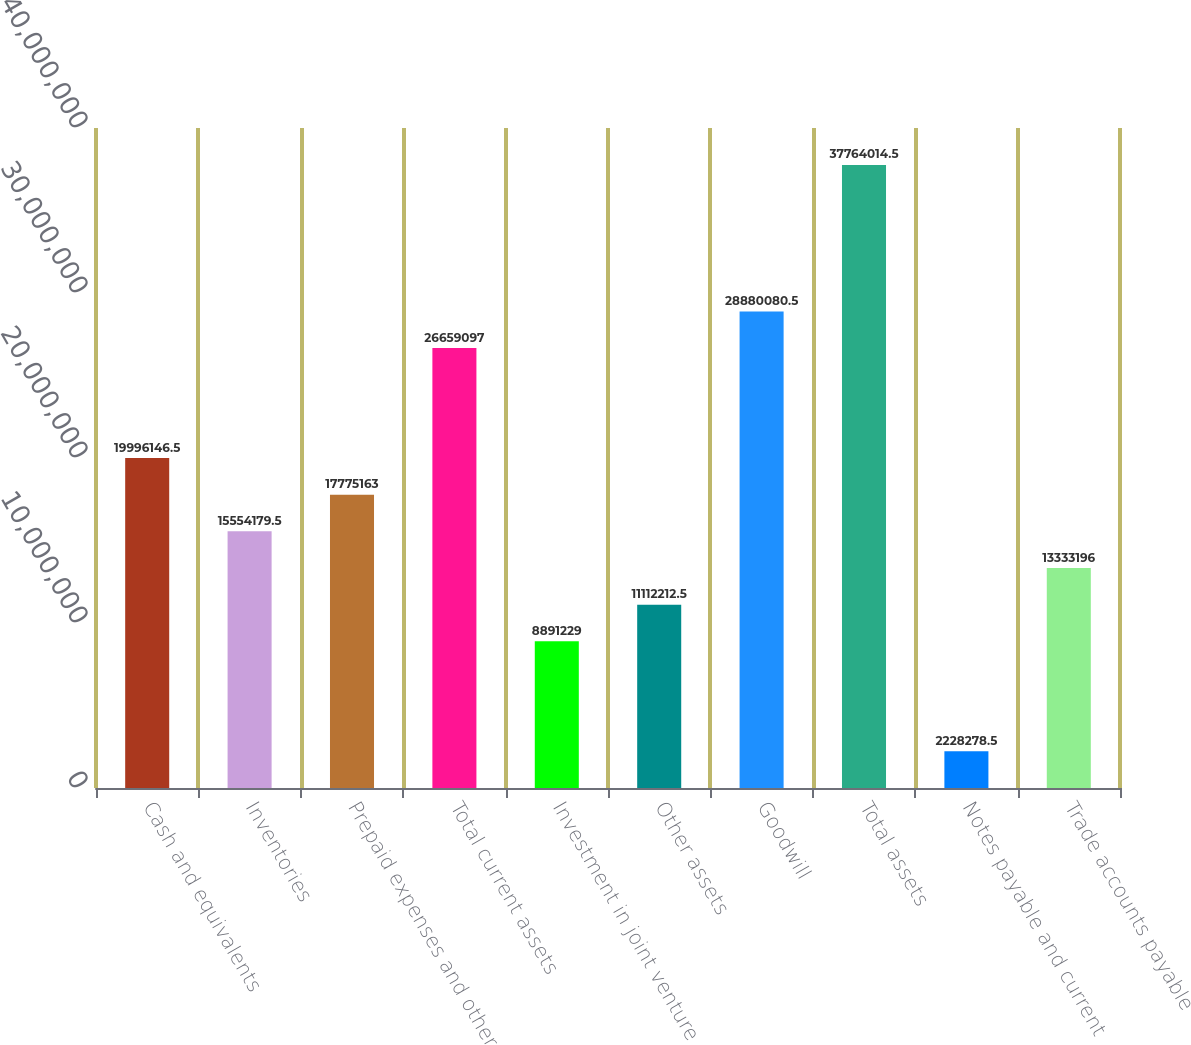Convert chart to OTSL. <chart><loc_0><loc_0><loc_500><loc_500><bar_chart><fcel>Cash and equivalents<fcel>Inventories<fcel>Prepaid expenses and other<fcel>Total current assets<fcel>Investment in joint venture<fcel>Other assets<fcel>Goodwill<fcel>Total assets<fcel>Notes payable and current<fcel>Trade accounts payable<nl><fcel>1.99961e+07<fcel>1.55542e+07<fcel>1.77752e+07<fcel>2.66591e+07<fcel>8.89123e+06<fcel>1.11122e+07<fcel>2.88801e+07<fcel>3.7764e+07<fcel>2.22828e+06<fcel>1.33332e+07<nl></chart> 